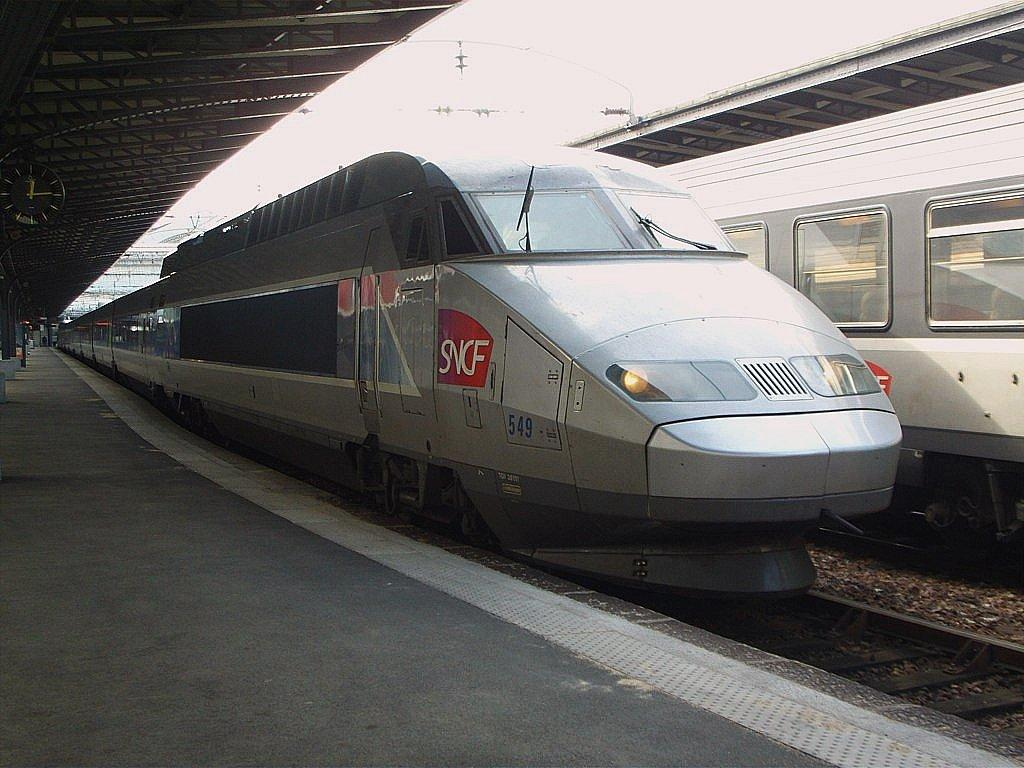<image>
Share a concise interpretation of the image provided. A silver bullet train is at the station and says SNCF on the side. 